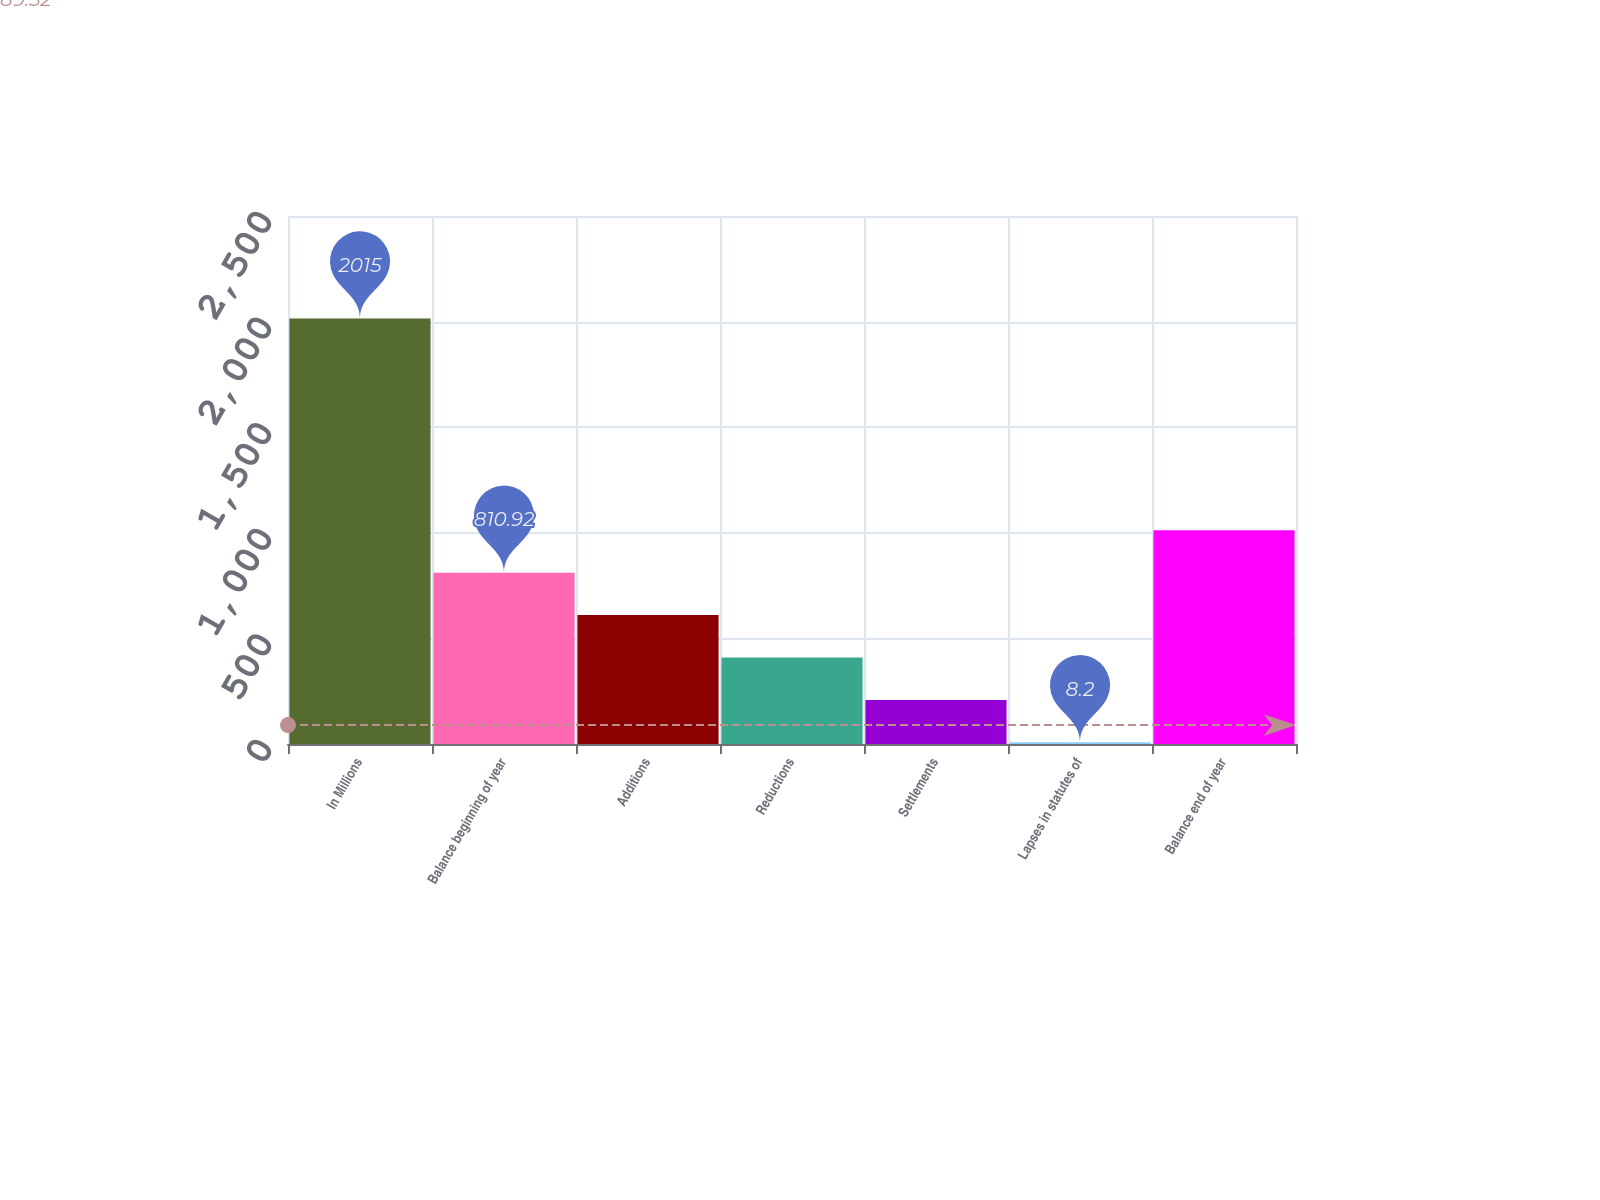Convert chart. <chart><loc_0><loc_0><loc_500><loc_500><bar_chart><fcel>In Millions<fcel>Balance beginning of year<fcel>Additions<fcel>Reductions<fcel>Settlements<fcel>Lapses in statutes of<fcel>Balance end of year<nl><fcel>2015<fcel>810.92<fcel>610.24<fcel>409.56<fcel>208.88<fcel>8.2<fcel>1011.6<nl></chart> 